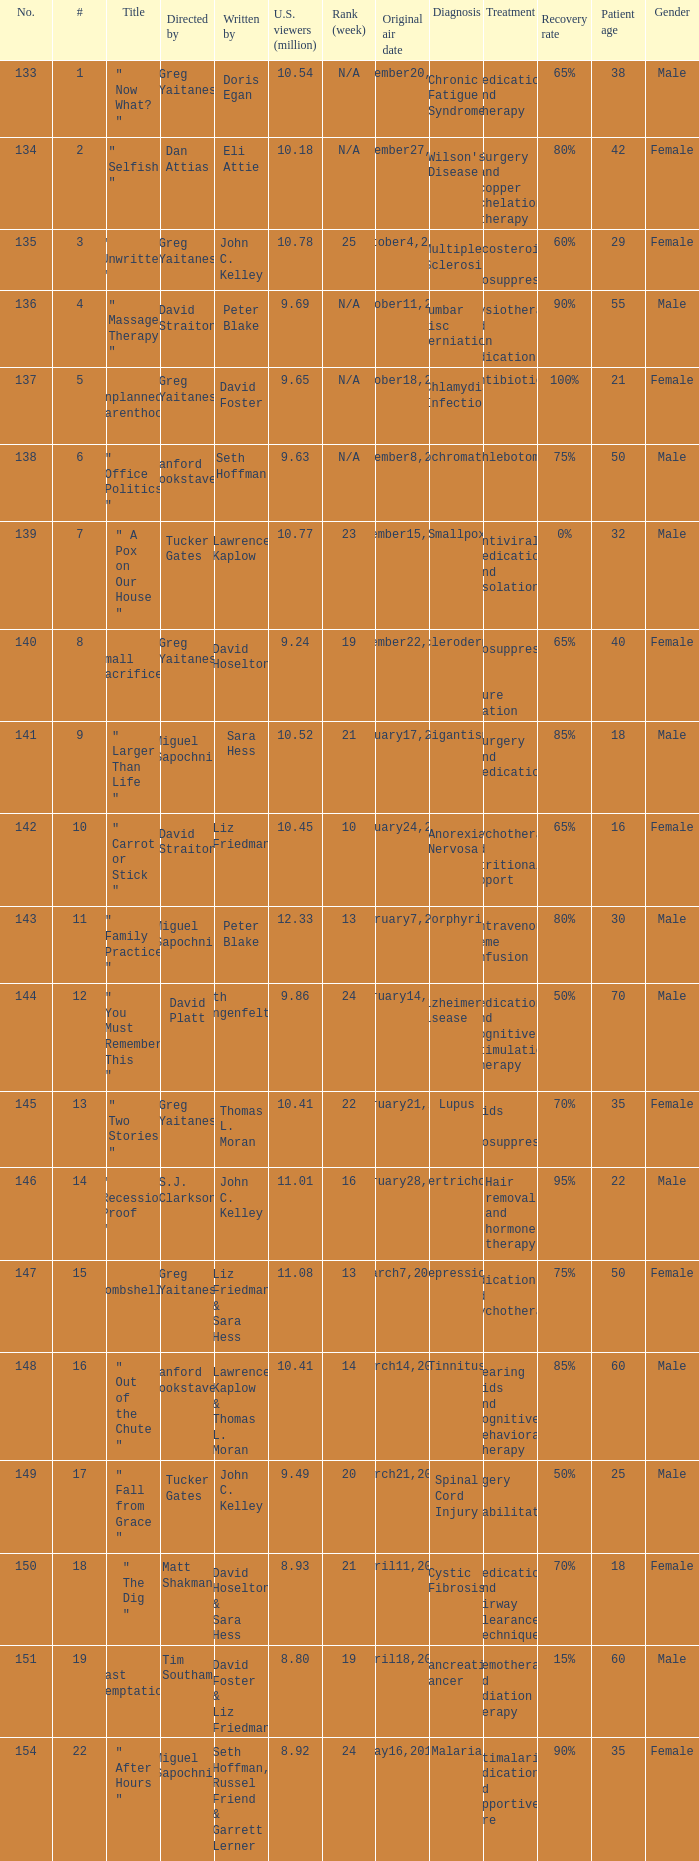How many episodes were written by seth hoffman, russel friend & garrett lerner? 1.0. 